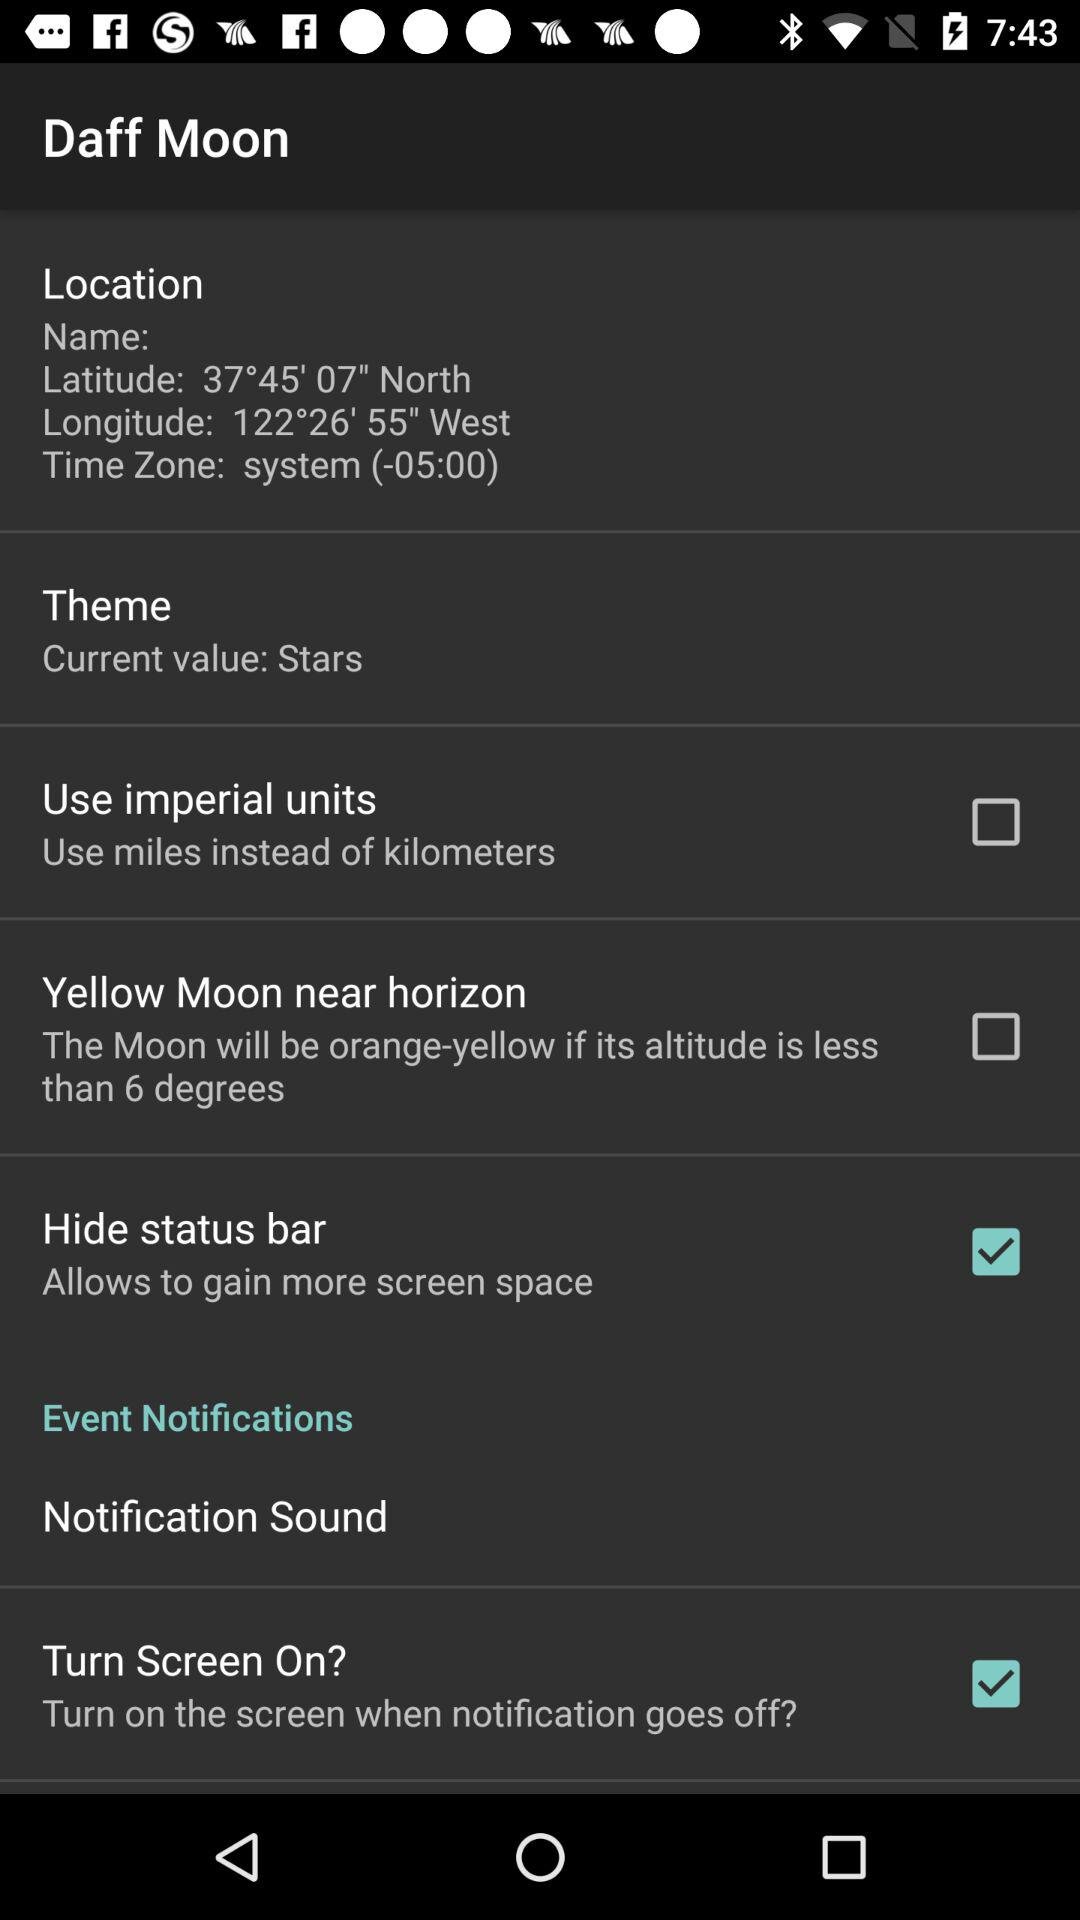How many degrees is the yellow moon threshold?
Answer the question using a single word or phrase. 6 